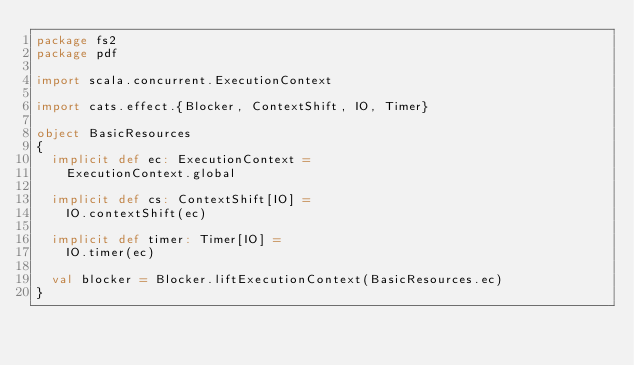Convert code to text. <code><loc_0><loc_0><loc_500><loc_500><_Scala_>package fs2
package pdf

import scala.concurrent.ExecutionContext

import cats.effect.{Blocker, ContextShift, IO, Timer}

object BasicResources
{
  implicit def ec: ExecutionContext =
    ExecutionContext.global

  implicit def cs: ContextShift[IO] =
    IO.contextShift(ec)

  implicit def timer: Timer[IO] =
    IO.timer(ec)

  val blocker = Blocker.liftExecutionContext(BasicResources.ec)
}
</code> 